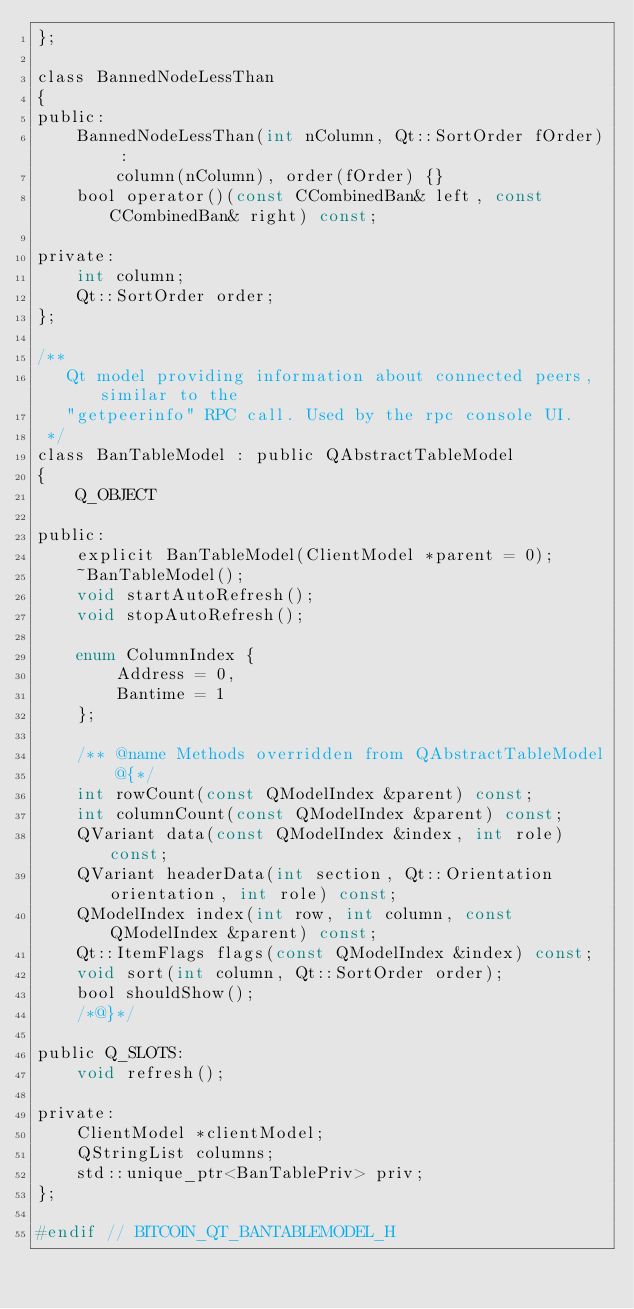<code> <loc_0><loc_0><loc_500><loc_500><_C_>};

class BannedNodeLessThan
{
public:
    BannedNodeLessThan(int nColumn, Qt::SortOrder fOrder) :
        column(nColumn), order(fOrder) {}
    bool operator()(const CCombinedBan& left, const CCombinedBan& right) const;

private:
    int column;
    Qt::SortOrder order;
};

/**
   Qt model providing information about connected peers, similar to the
   "getpeerinfo" RPC call. Used by the rpc console UI.
 */
class BanTableModel : public QAbstractTableModel
{
    Q_OBJECT

public:
    explicit BanTableModel(ClientModel *parent = 0);
    ~BanTableModel();
    void startAutoRefresh();
    void stopAutoRefresh();

    enum ColumnIndex {
        Address = 0,
        Bantime = 1
    };

    /** @name Methods overridden from QAbstractTableModel
        @{*/
    int rowCount(const QModelIndex &parent) const;
    int columnCount(const QModelIndex &parent) const;
    QVariant data(const QModelIndex &index, int role) const;
    QVariant headerData(int section, Qt::Orientation orientation, int role) const;
    QModelIndex index(int row, int column, const QModelIndex &parent) const;
    Qt::ItemFlags flags(const QModelIndex &index) const;
    void sort(int column, Qt::SortOrder order);
    bool shouldShow();
    /*@}*/

public Q_SLOTS:
    void refresh();

private:
    ClientModel *clientModel;
    QStringList columns;
    std::unique_ptr<BanTablePriv> priv;
};

#endif // BITCOIN_QT_BANTABLEMODEL_H
</code> 